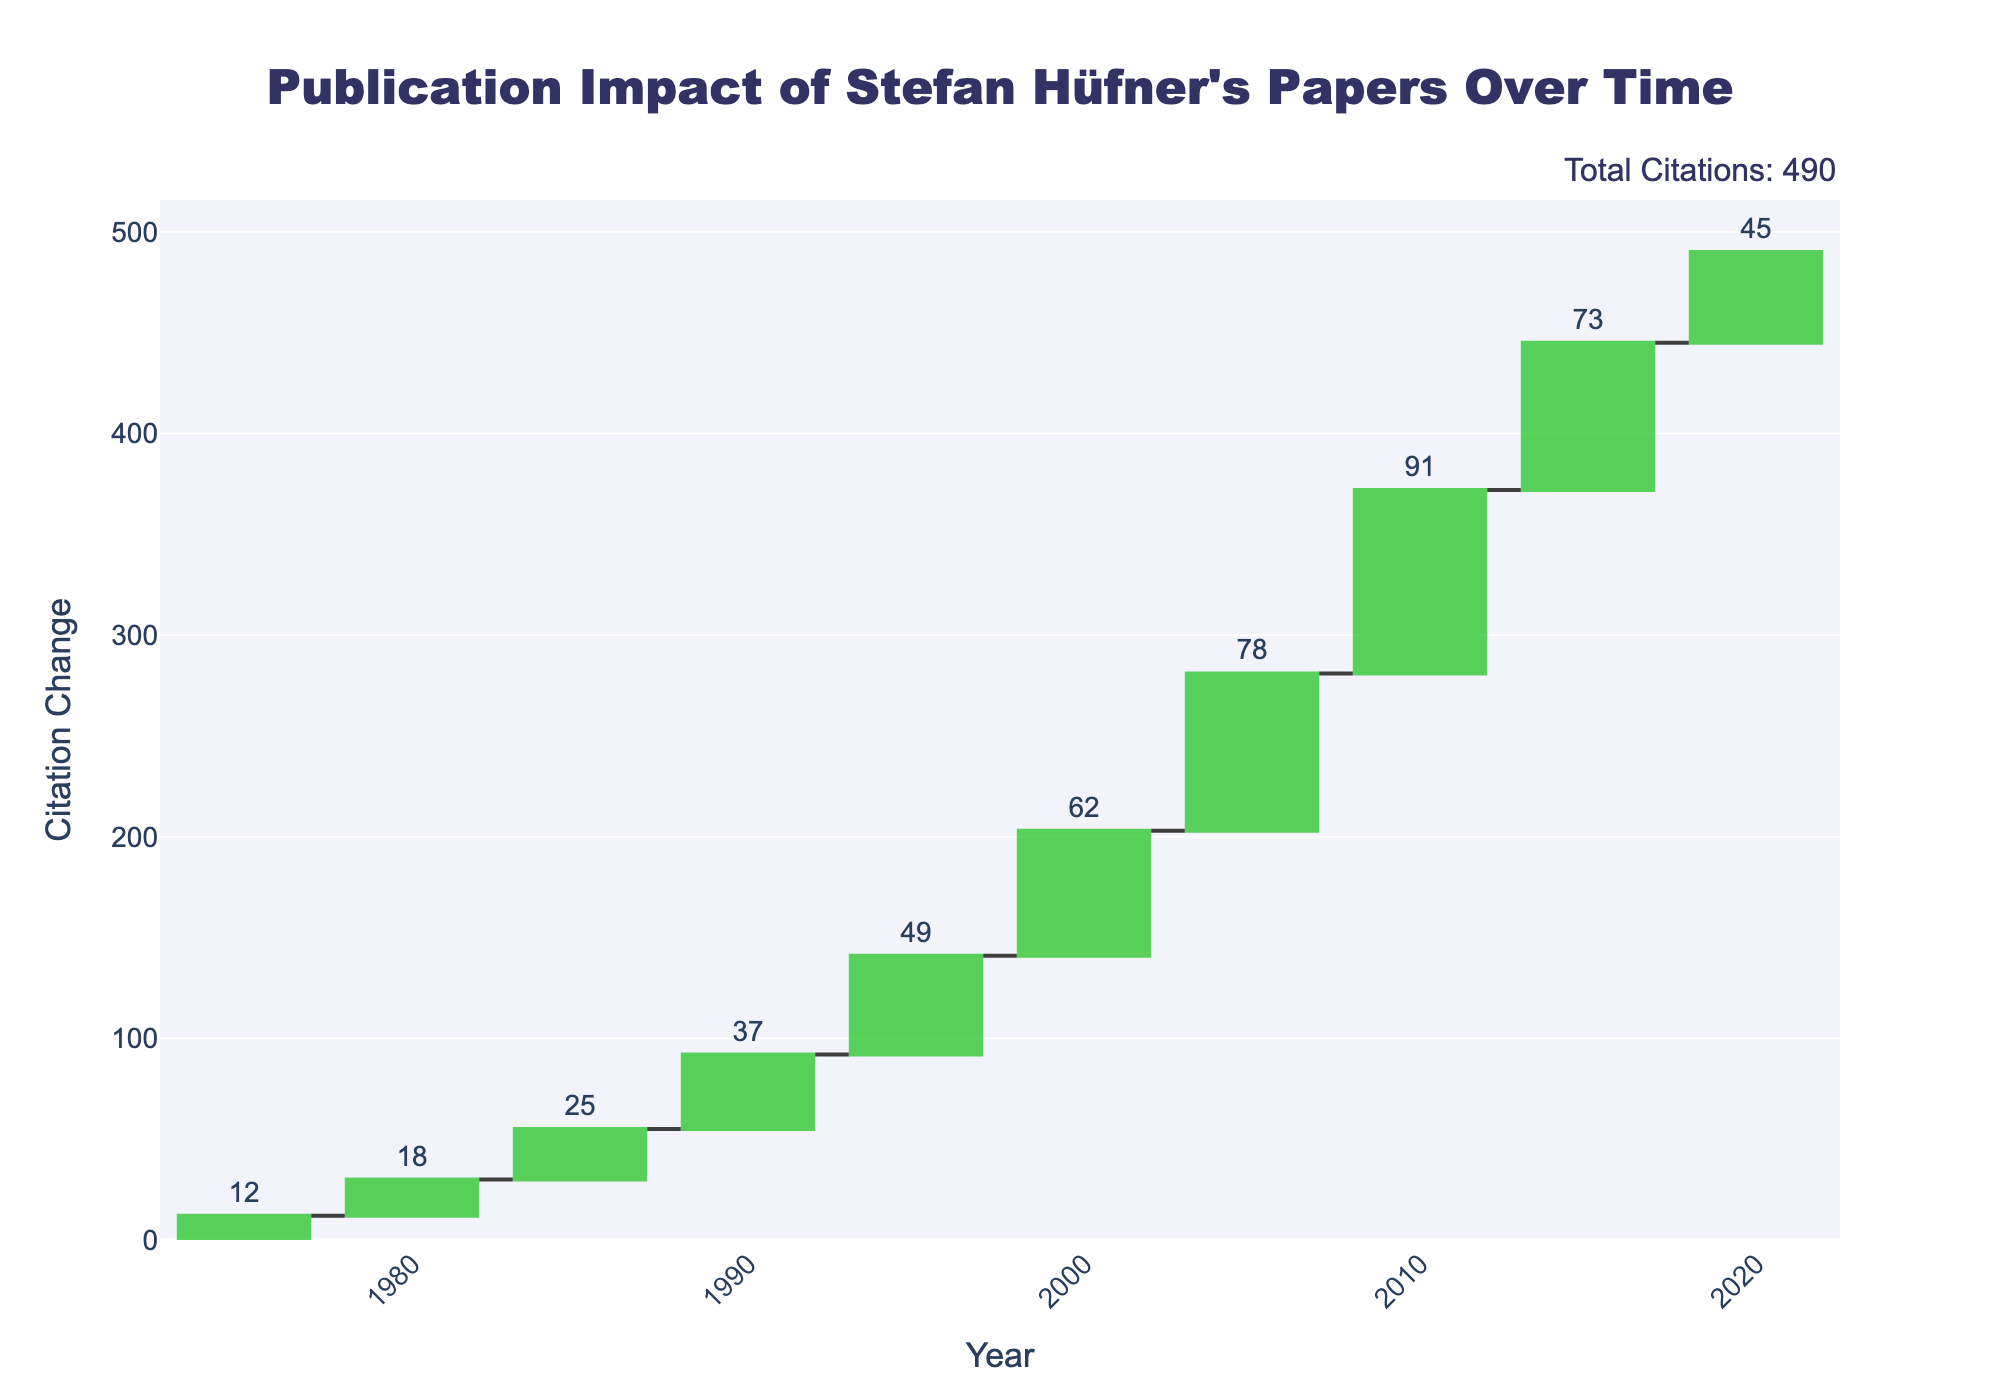What's the title of the chart? The title of the chart is usually displayed at the top of the plot.
Answer: Publication Impact of Stefan Hüfner's Papers Over Time What is the cumulative citation change by the year 2000? The cumulative citation change can be found by summing up the individual changes from 1975 to 2000. These changes are 12, 18, 25, 37, 49, and 62. Adding them gives 12 + 18 + 25 + 37 + 49 + 62 = 203.
Answer: 203 Which year showed the highest incremental change in citations? By looking at the bars in the waterfall chart, the tallest bar represents the highest incremental change. The highest bar corresponds to the year 2010.
Answer: 2010 How many years experienced citation changes greater than 50? By examining the height of the bars and their labels, we identify the years 2000, 2005, 2010, and 2015 with changes of 62, 78, 91, and 73 respectively. These are all greater than 50.
Answer: 4 How does the citation change in 2015 compare to the change in 2020? By comparing the heights and labels of the bars for 2015 and 2020, we see that the change in 2015 is 73, and the change in 2020 is 45. Therefore, the change in 2015 is greater than in 2020.
Answer: The change in 2015 is greater What is the average citation change over the entire period? The average citation change can be calculated by summing all the citation changes and then dividing by the number of years. Sum: 12 + 18 + 25 + 37 + 49 + 62 + 78 + 91 + 73 + 45 = 490. Number of years: 10. Average = 490 / 10 = 49.
Answer: 49 What color represents the increasing changes in citations? The chart uses colors to differentiate changes. The legend or visual inspection shows that increasing changes are represented in green.
Answer: Green Does the chart show any years with a decrease in citations? By examining the colors and direction of the bars in the waterfall chart, all bars are shown as increases without any downward or red bars indicating a decrease.
Answer: No Is the total citation change for all years greater than 450? Summing up the incremental changes from all years: 12 + 18 + 25 + 37 + 49 + 62 + 78 + 91 + 73 + 45 = 490. Since 490 is greater than 450, the total citation change exceeds 450.
Answer: Yes 